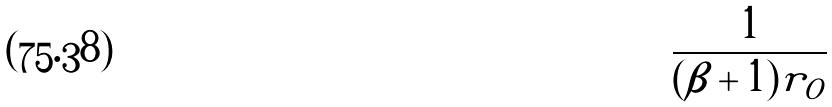Convert formula to latex. <formula><loc_0><loc_0><loc_500><loc_500>\frac { 1 } { ( \beta + 1 ) r _ { O } }</formula> 